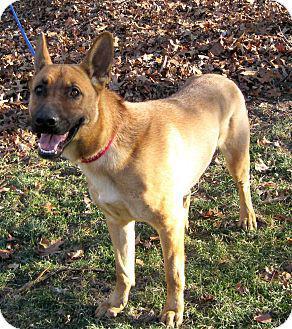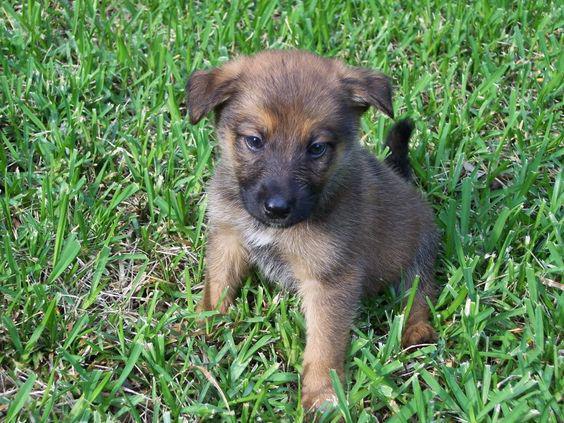The first image is the image on the left, the second image is the image on the right. Analyze the images presented: Is the assertion "the dog's tongue is extended in one of the images" valid? Answer yes or no. No. The first image is the image on the left, the second image is the image on the right. Assess this claim about the two images: "At least one image has no grass.". Correct or not? Answer yes or no. No. 